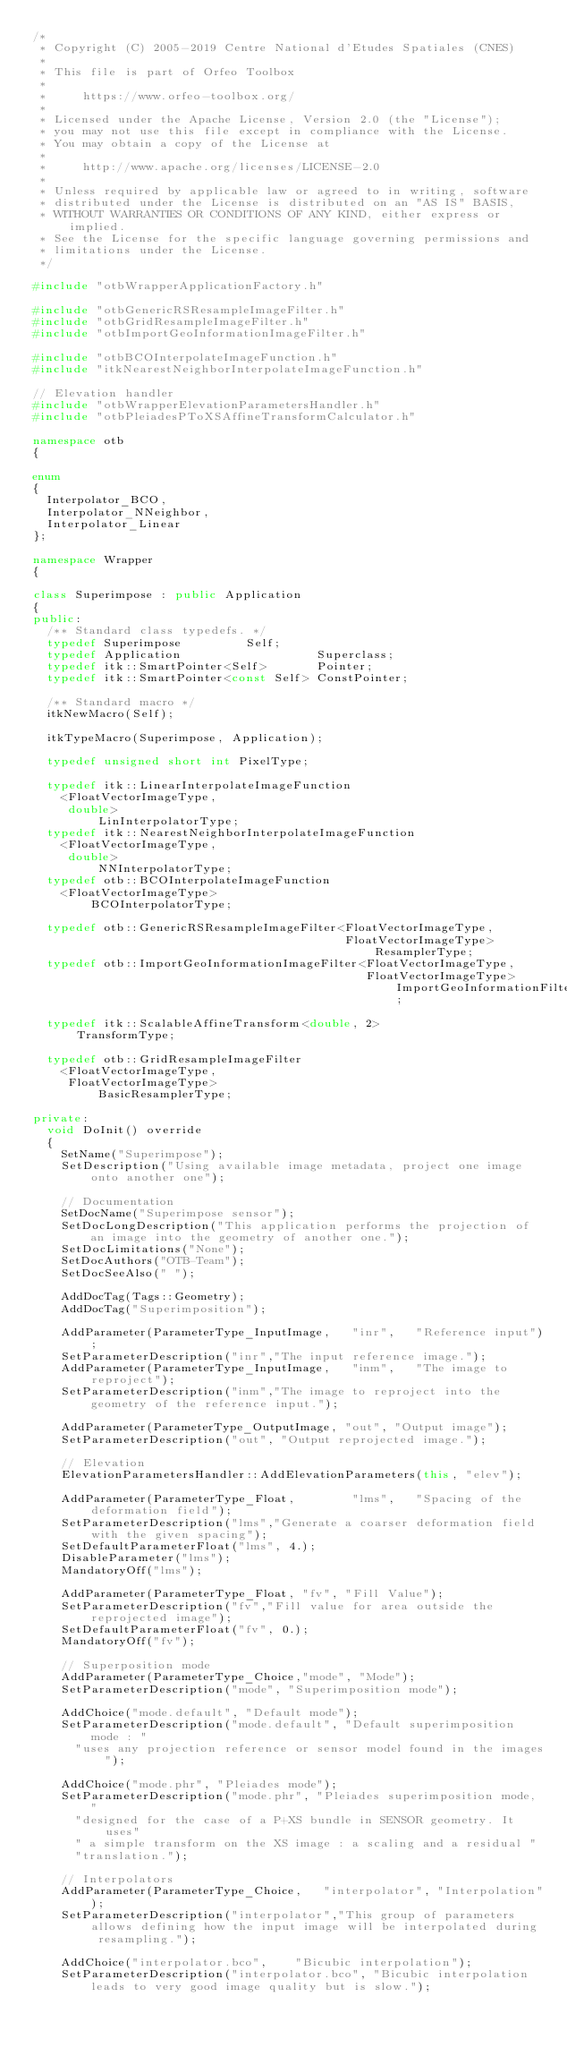Convert code to text. <code><loc_0><loc_0><loc_500><loc_500><_C++_>/*
 * Copyright (C) 2005-2019 Centre National d'Etudes Spatiales (CNES)
 *
 * This file is part of Orfeo Toolbox
 *
 *     https://www.orfeo-toolbox.org/
 *
 * Licensed under the Apache License, Version 2.0 (the "License");
 * you may not use this file except in compliance with the License.
 * You may obtain a copy of the License at
 *
 *     http://www.apache.org/licenses/LICENSE-2.0
 *
 * Unless required by applicable law or agreed to in writing, software
 * distributed under the License is distributed on an "AS IS" BASIS,
 * WITHOUT WARRANTIES OR CONDITIONS OF ANY KIND, either express or implied.
 * See the License for the specific language governing permissions and
 * limitations under the License.
 */

#include "otbWrapperApplicationFactory.h"

#include "otbGenericRSResampleImageFilter.h"
#include "otbGridResampleImageFilter.h"
#include "otbImportGeoInformationImageFilter.h"

#include "otbBCOInterpolateImageFunction.h"
#include "itkNearestNeighborInterpolateImageFunction.h"

// Elevation handler
#include "otbWrapperElevationParametersHandler.h"
#include "otbPleiadesPToXSAffineTransformCalculator.h"

namespace otb
{

enum
{
  Interpolator_BCO,
  Interpolator_NNeighbor,
  Interpolator_Linear
};

namespace Wrapper
{

class Superimpose : public Application
{
public:
  /** Standard class typedefs. */
  typedef Superimpose         Self;
  typedef Application                   Superclass;
  typedef itk::SmartPointer<Self>       Pointer;
  typedef itk::SmartPointer<const Self> ConstPointer;

  /** Standard macro */
  itkNewMacro(Self);

  itkTypeMacro(Superimpose, Application);

  typedef unsigned short int PixelType;

  typedef itk::LinearInterpolateImageFunction
    <FloatVectorImageType,
     double>                                                      LinInterpolatorType;
  typedef itk::NearestNeighborInterpolateImageFunction
    <FloatVectorImageType,
     double>                                                      NNInterpolatorType;
  typedef otb::BCOInterpolateImageFunction
    <FloatVectorImageType>                                        BCOInterpolatorType;

  typedef otb::GenericRSResampleImageFilter<FloatVectorImageType,
                                            FloatVectorImageType>  ResamplerType;
  typedef otb::ImportGeoInformationImageFilter<FloatVectorImageType,
                                               FloatVectorImageType> ImportGeoInformationFilterType;

  typedef itk::ScalableAffineTransform<double, 2>                 TransformType;
  
  typedef otb::GridResampleImageFilter
    <FloatVectorImageType,
     FloatVectorImageType>                                        BasicResamplerType;
  
private:
  void DoInit() override
  {
    SetName("Superimpose");
    SetDescription("Using available image metadata, project one image onto another one");

    // Documentation
    SetDocName("Superimpose sensor");
    SetDocLongDescription("This application performs the projection of an image into the geometry of another one.");
    SetDocLimitations("None");
    SetDocAuthors("OTB-Team");
    SetDocSeeAlso(" ");

    AddDocTag(Tags::Geometry);
    AddDocTag("Superimposition");

    AddParameter(ParameterType_InputImage,   "inr",   "Reference input");
    SetParameterDescription("inr","The input reference image.");
    AddParameter(ParameterType_InputImage,   "inm",   "The image to reproject");
    SetParameterDescription("inm","The image to reproject into the geometry of the reference input.");

    AddParameter(ParameterType_OutputImage, "out", "Output image");
    SetParameterDescription("out", "Output reprojected image.");

    // Elevation
    ElevationParametersHandler::AddElevationParameters(this, "elev");

    AddParameter(ParameterType_Float,        "lms",   "Spacing of the deformation field");
    SetParameterDescription("lms","Generate a coarser deformation field with the given spacing");
    SetDefaultParameterFloat("lms", 4.);
    DisableParameter("lms");
    MandatoryOff("lms");

    AddParameter(ParameterType_Float, "fv", "Fill Value");
    SetParameterDescription("fv","Fill value for area outside the reprojected image");
    SetDefaultParameterFloat("fv", 0.);
    MandatoryOff("fv");

    // Superposition mode
    AddParameter(ParameterType_Choice,"mode", "Mode");
    SetParameterDescription("mode", "Superimposition mode");
    
    AddChoice("mode.default", "Default mode");
    SetParameterDescription("mode.default", "Default superimposition mode : "
      "uses any projection reference or sensor model found in the images");
    
    AddChoice("mode.phr", "Pleiades mode");
    SetParameterDescription("mode.phr", "Pleiades superimposition mode, "
      "designed for the case of a P+XS bundle in SENSOR geometry. It uses"
      " a simple transform on the XS image : a scaling and a residual "
      "translation.");
    
    // Interpolators
    AddParameter(ParameterType_Choice,   "interpolator", "Interpolation");
    SetParameterDescription("interpolator","This group of parameters allows defining how the input image will be interpolated during resampling.");

    AddChoice("interpolator.bco",    "Bicubic interpolation");
    SetParameterDescription("interpolator.bco", "Bicubic interpolation leads to very good image quality but is slow.");
</code> 